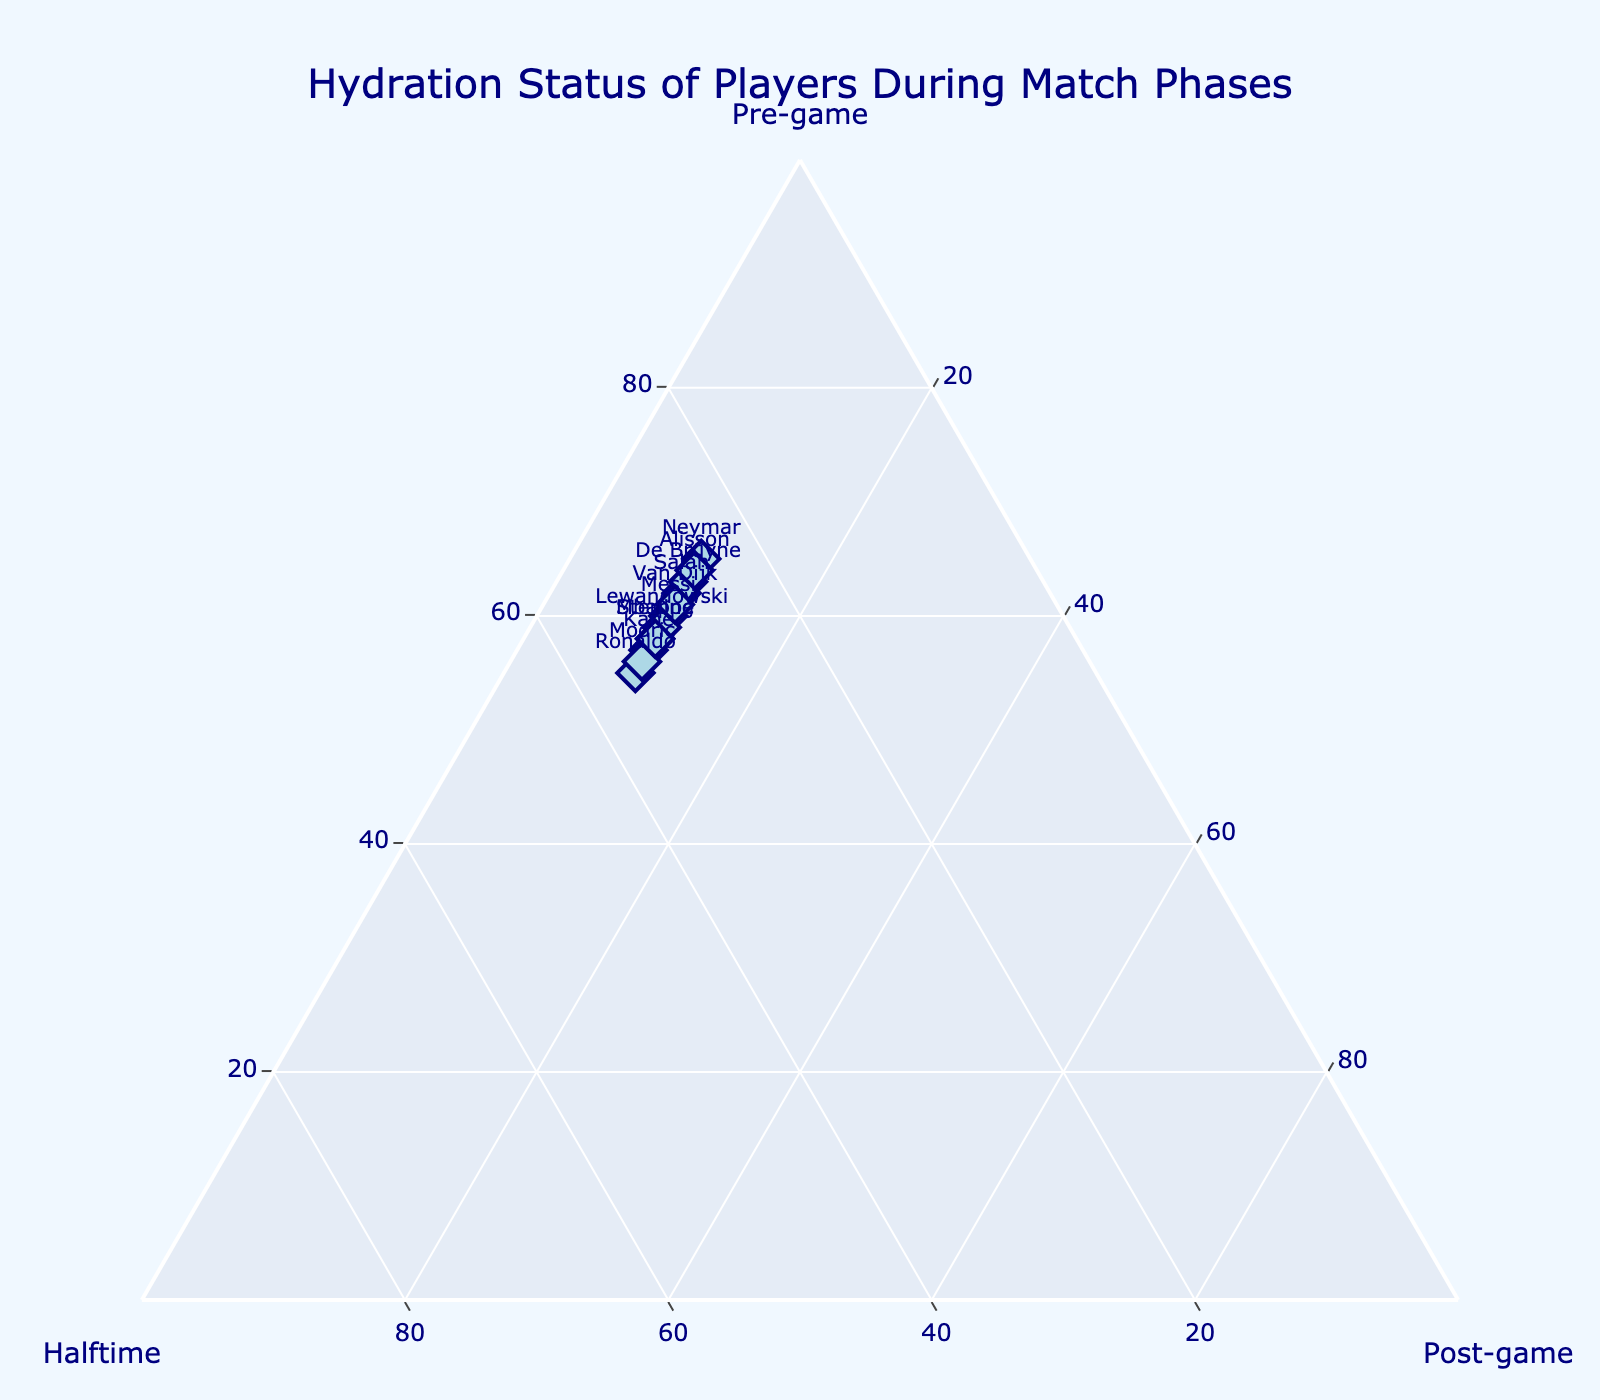What is the title of the plot? The title of the plot is usually displayed at the top of the figure and provides an overview of what the plot represents. In this case, it is written as "Hydration Status of Players During Match Phases".
Answer: Hydration Status of Players During Match Phases What are the phases represented on the axes of the ternary plot? The ternary plot has three axes, each representing one of the phases of the match: 'Pre-game', 'Halftime', and 'Post-game', as indicated by the labels on each axis.
Answer: Pre-game, Halftime, Post-game How many players' hydration statuses are displayed in the plot? There are multiple markers in the plot, each representing a player. By counting the players listed, we can see that there are 12 players.
Answer: 12 Which player has the highest pre-game hydration level? To determine which player has the highest pre-game hydration level, look for the player whose marker is closest to the 'Pre-game' apex of the ternary plot. From the data, Neymar has the highest pre-game hydration level of 65%.
Answer: Neymar Which phase shows the lowest variability in hydration levels amongst the players? To find the phase with the lowest variability, observe the spread of hydration levels along each axis. The 'Post-game' phase shows the least spread as all players have post-game hydration levels close to 10%.
Answer: Post-game What is the average pre-game hydration level of all players? Sum up all pre-game hydration levels and divide by the number of players: (60 + 55 + 65 + 58 + 62 + 57 + 63 + 59 + 61 + 64 + 56 + 58) / 12 = 718 / 12 = 59.83%.
Answer: 59.83% What is the difference in pre-game hydration levels between Messi and Alisson? Subtract Messi's pre-game hydration level from Alisson's: 64% - 60% = 4%.
Answer: 4% Which player shows the largest decrease in hydration level from halftime to post-game? To find this, compare the hydration levels from halftime to post-game for each player and identify the maximum difference. Since all players have a consistent decrease of 25% (halftime to post-game value minus post-game constant 10%), the difference is uniform across players.
Answer: All players show a 25% decrease How does Salah’s hydration level at halftime compare to De Bruyne’s? Compare the halftime hydration levels of Salah and De Bruyne from the data provided. Salah's halftime level is 28%, and De Bruyne's is 27%. Salah has a slightly higher level than De Bruyne.
Answer: Salah’s hydration level is higher by 1% Which player shows the smallest decrease in hydration from pre-game to halftime? Look for the player with the smallest difference between pre-game and halftime hydration levels. By checking each value: Messi (30%), Ronaldo (20%), Neymar (40%), Mbappe (26%), Salah (34%), Kane (24%), De Bruyne (36%), Lewandowski (28%), Van Dijk (32%), Alisson (38%), Modric (22%), Sterling (26%), the smallest difference is seen in Modric with 22%.
Answer: Modric 